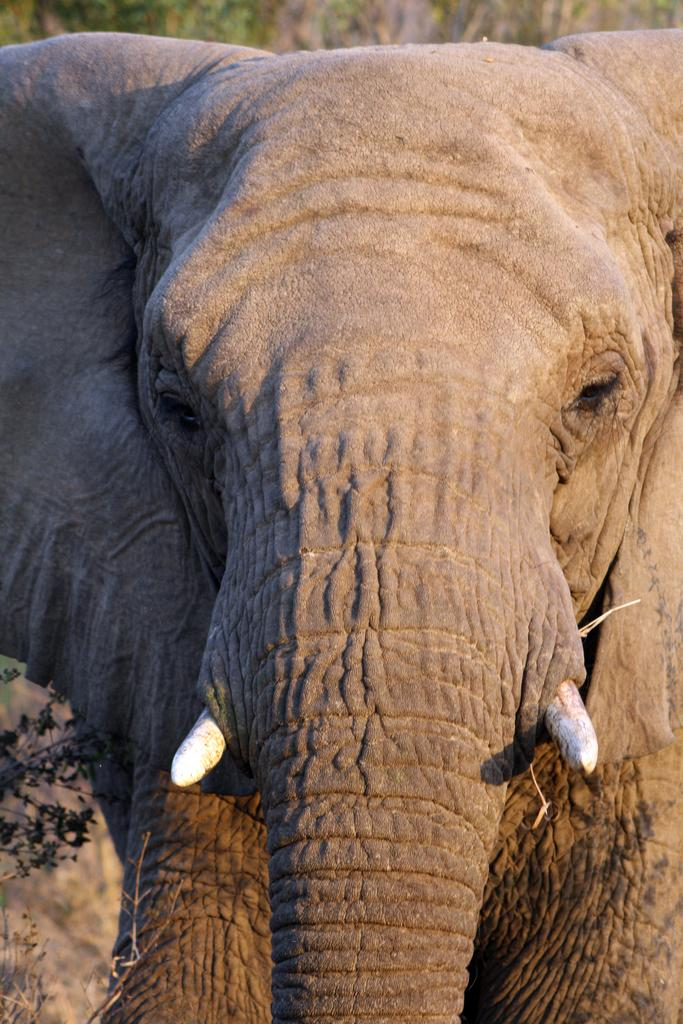What animal is the main subject of the image? There is an elephant in the image. What color is the elephant? The elephant is brown in color. What can be seen in the background of the image? There are many trees in the background of the image. What type of sign is the elephant holding in the image? There is no sign present in the image; the elephant is not holding anything. 